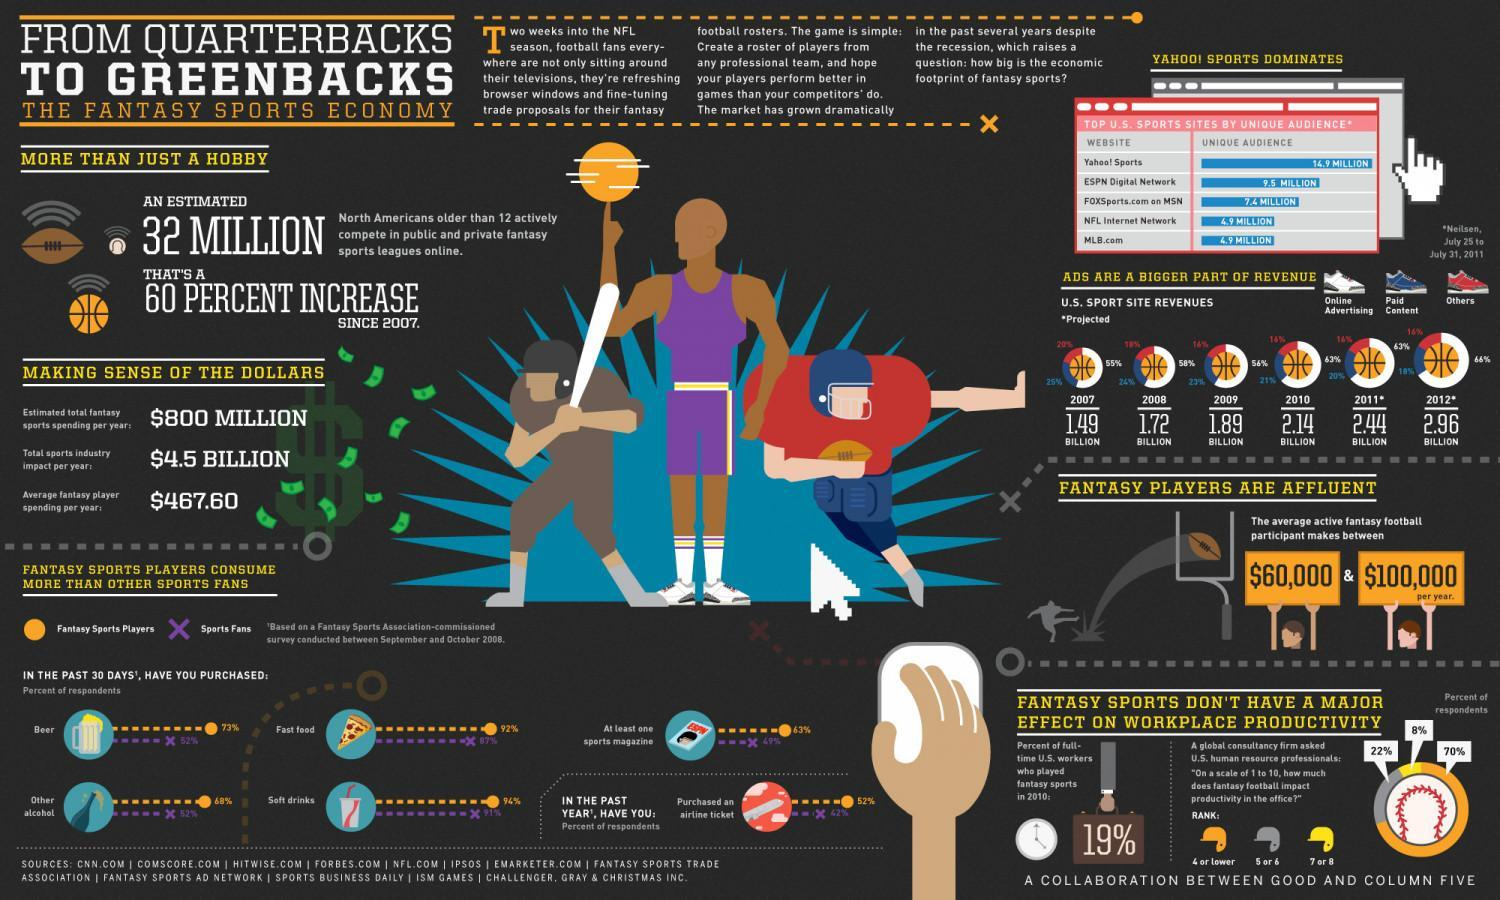What % was the US sports site revenue in 2009 from online advertising
Answer the question with a short phrase. 56% how many teenagers and above North Americans actively compete in public and private fantasy sports leagues online 32 million In the past 30 days, what has 52% not purchased beer, other alcohol What % of respondents ranted 7 or 8 on the question of how much does fantasy football impact productivity in the office? 8% WHat is the amount that an average active fantasy football participant make per year between $60,000 & $100,000 What % was the US sports site revenue in 2009 from paid content 23% What is the US Sports site projected revenuw in 2011 2.44 billion What % was the US sports site revenue in 2009 from others 14% 